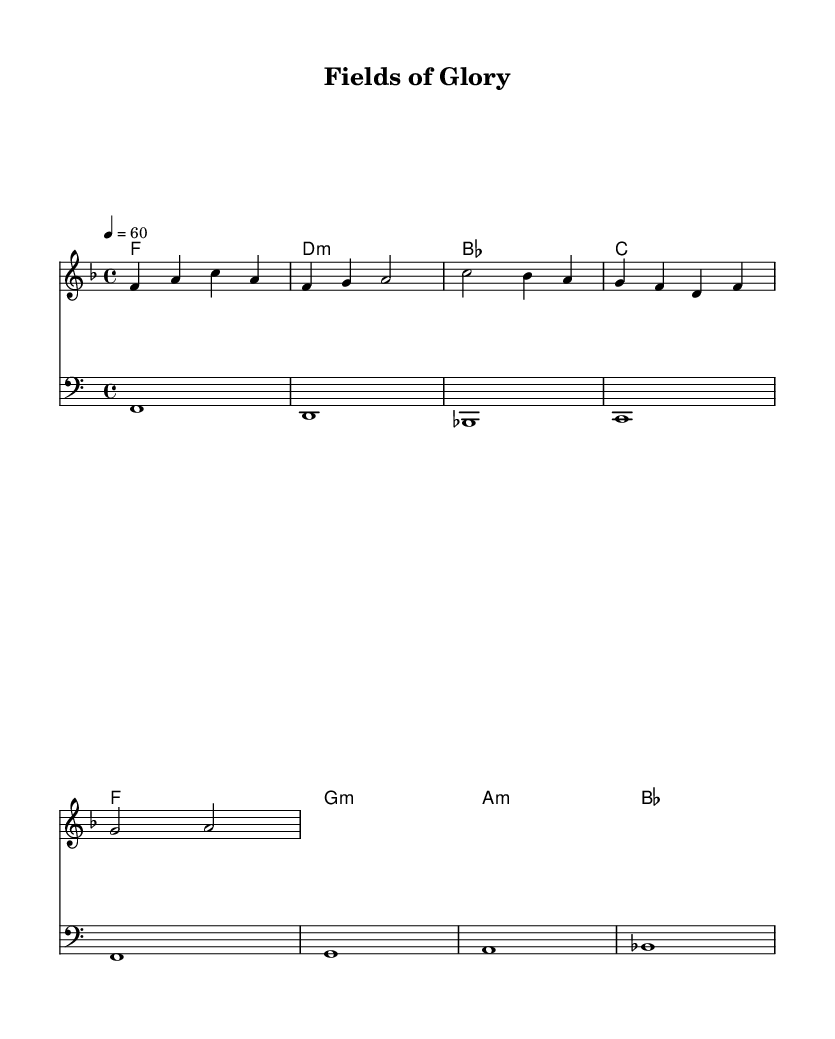What is the key signature of this music? The key signature is indicated at the beginning of the staff and shows one flat, which confirms that the piece is in F major.
Answer: F major What is the time signature of this music? The time signature is represented in the music notation at the beginning, showing a "4/4" time, meaning four beats per measure.
Answer: 4/4 What is the tempo marking of this piece? The tempo marking indicates "4 = 60", meaning there are 60 beats per minute, which reflects a slow to moderate pace for the piece.
Answer: 60 How many measures are in the melody section? Counting the bars indicates that there are four measures in the melody section, as indicated by the vertical lines.
Answer: 4 Which chord corresponds with the first measure? The first measure of the harmony section is labeled with the chord "F", which represents the chord played in that measure.
Answer: F What is the lyrical theme of this ballad? Analyzing the lyrics, they reflect the pride and passion found in sports, celebrating the legends and their legacy through imagery associated with fields and the ongoing nature of the sport.
Answer: Legends and legacy 